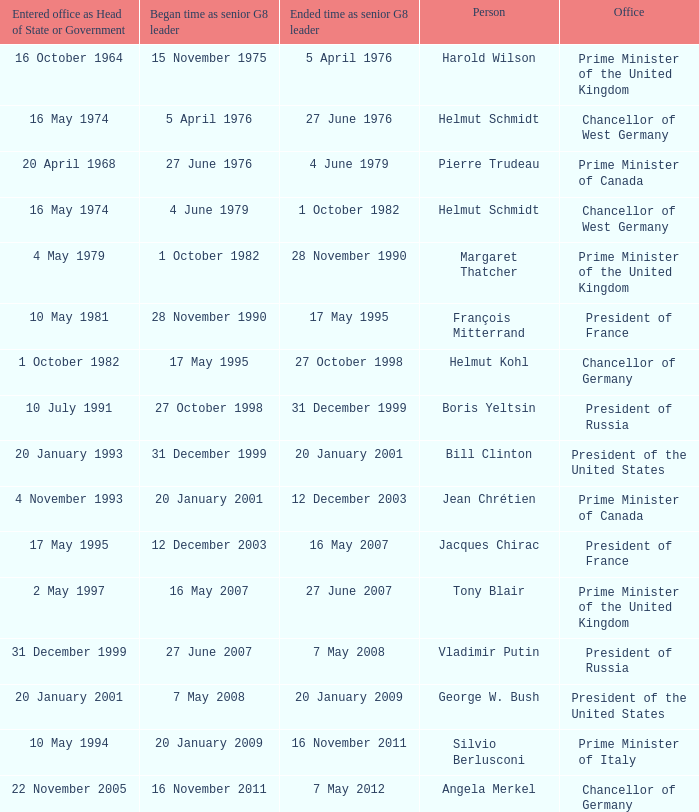When did Jacques Chirac stop being a G8 leader? 16 May 2007. 